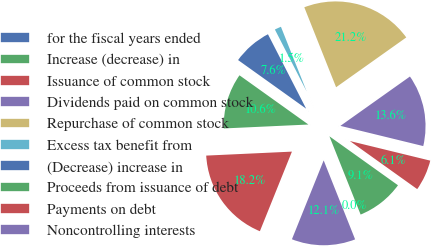Convert chart. <chart><loc_0><loc_0><loc_500><loc_500><pie_chart><fcel>for the fiscal years ended<fcel>Increase (decrease) in<fcel>Issuance of common stock<fcel>Dividends paid on common stock<fcel>Repurchase of common stock<fcel>Excess tax benefit from<fcel>(Decrease) increase in<fcel>Proceeds from issuance of debt<fcel>Payments on debt<fcel>Noncontrolling interests<nl><fcel>0.01%<fcel>9.09%<fcel>6.06%<fcel>13.63%<fcel>21.2%<fcel>1.52%<fcel>7.58%<fcel>10.61%<fcel>18.17%<fcel>12.12%<nl></chart> 